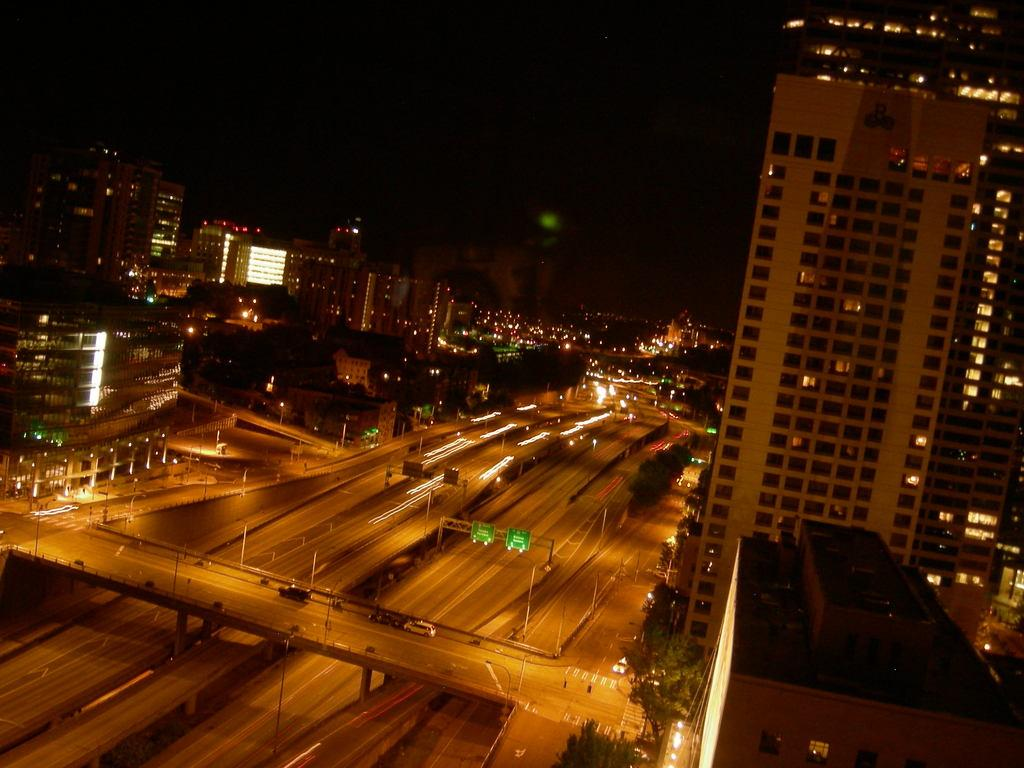What is the main feature of the image? There is a road in the image. What is happening on the road? Vehicles are moving on the road. What structure can be seen in the image? There is a bridge in the image. What can be seen in the distance in the image? There are buildings in the background of the image. How would you describe the sky in the image? The sky is dark in the background of the image. What type of property can be seen in the mouth of the person in the image? There is no person or mouth present in the image; it features a road, vehicles, a bridge, buildings, and a dark sky. 